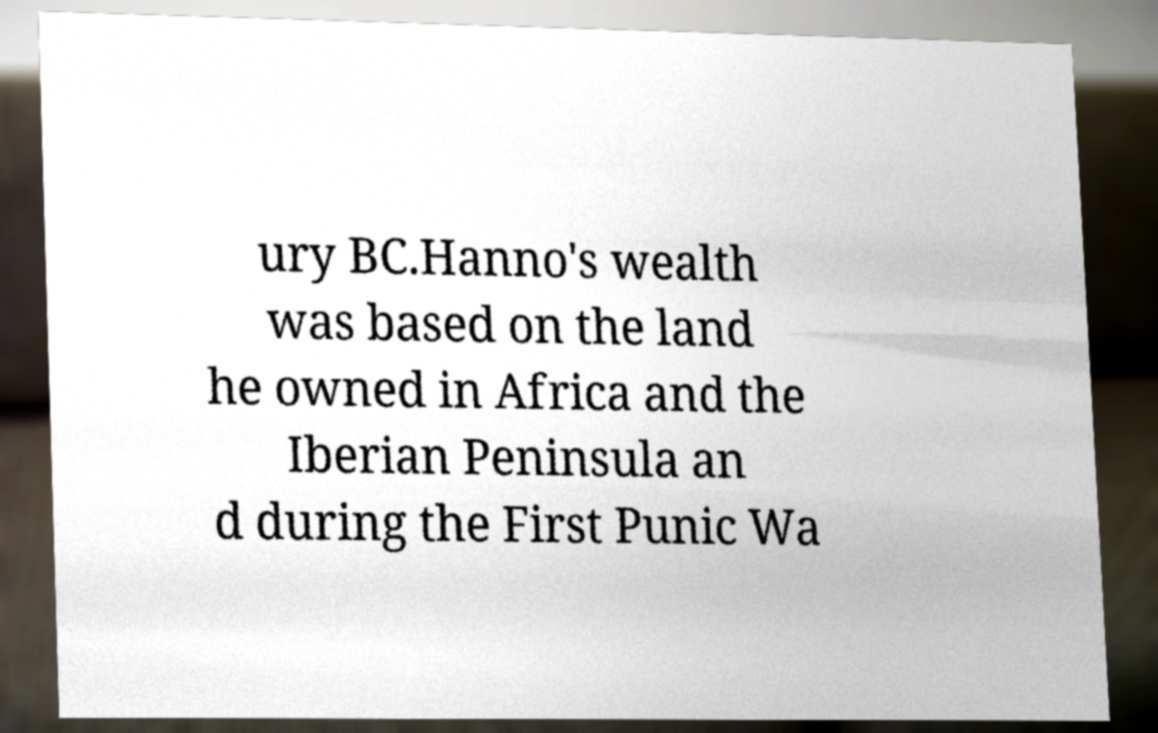There's text embedded in this image that I need extracted. Can you transcribe it verbatim? ury BC.Hanno's wealth was based on the land he owned in Africa and the Iberian Peninsula an d during the First Punic Wa 